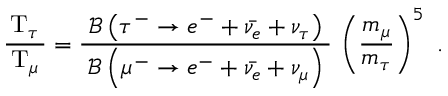Convert formula to latex. <formula><loc_0><loc_0><loc_500><loc_500>{ \frac { \, T _ { \tau } \, } { T _ { \mu } } } = { \frac { \, { \mathcal { B } } \left ( \tau ^ { - } \rightarrow e ^ { - } + { \bar { \nu _ { e } } } + \nu _ { \tau } \right ) \, } { { \mathcal { B } } \left ( \mu ^ { - } \rightarrow e ^ { - } + { \bar { \nu _ { e } } } + \nu _ { \mu } \right ) } } \, \left ( { \frac { m _ { \mu } } { m _ { \tau } } } \right ) ^ { 5 } .</formula> 